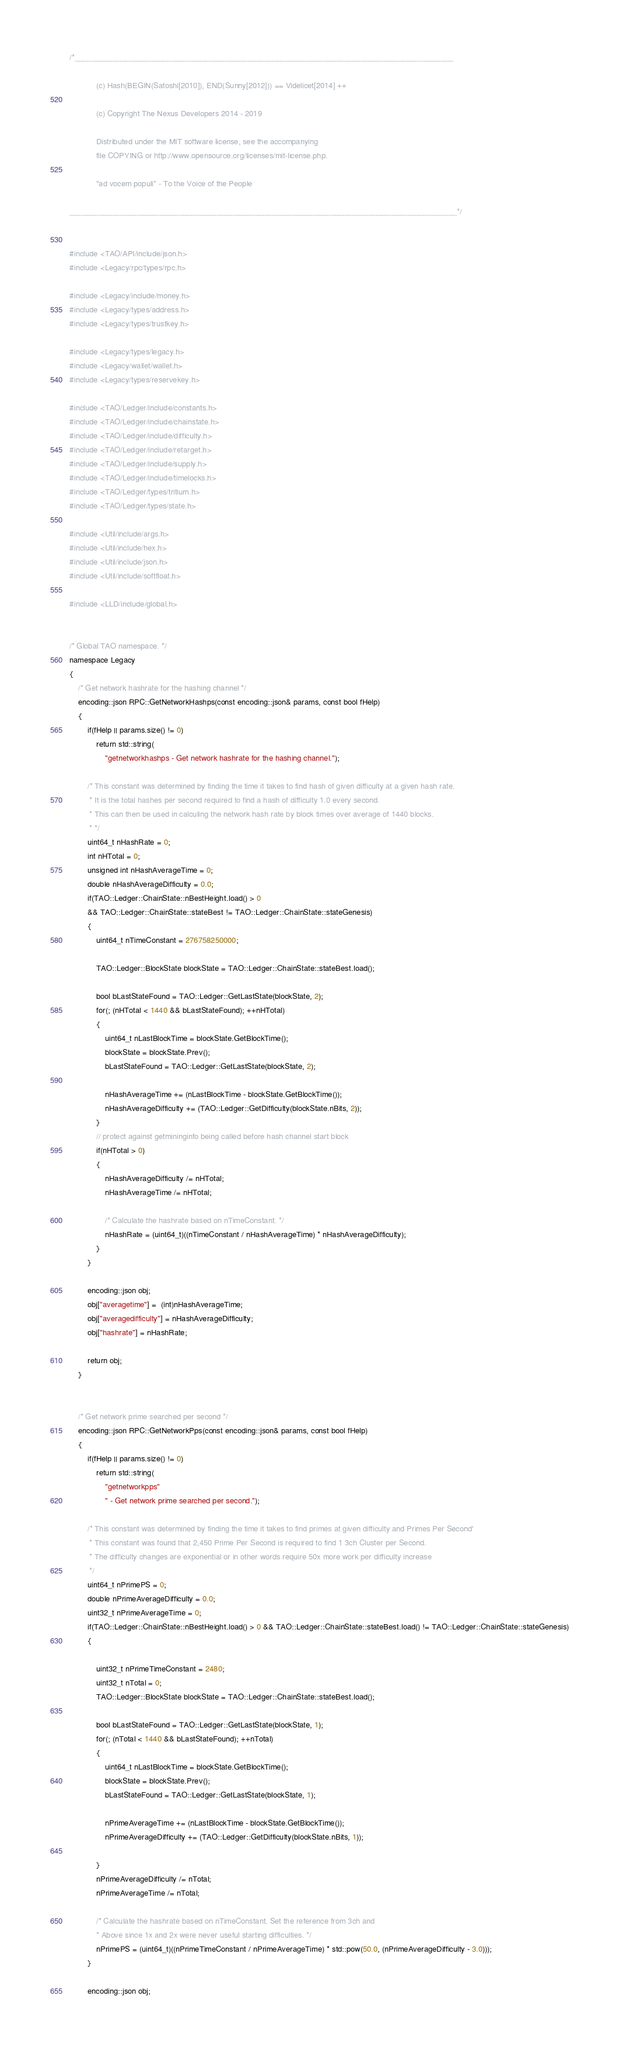Convert code to text. <code><loc_0><loc_0><loc_500><loc_500><_C++_>/*__________________________________________________________________________________________

            (c) Hash(BEGIN(Satoshi[2010]), END(Sunny[2012])) == Videlicet[2014] ++

            (c) Copyright The Nexus Developers 2014 - 2019

            Distributed under the MIT software license, see the accompanying
            file COPYING or http://www.opensource.org/licenses/mit-license.php.

            "ad vocem populi" - To the Voice of the People

____________________________________________________________________________________________*/


#include <TAO/API/include/json.h>
#include <Legacy/rpc/types/rpc.h>

#include <Legacy/include/money.h>
#include <Legacy/types/address.h>
#include <Legacy/types/trustkey.h>

#include <Legacy/types/legacy.h>
#include <Legacy/wallet/wallet.h>
#include <Legacy/types/reservekey.h>

#include <TAO/Ledger/include/constants.h>
#include <TAO/Ledger/include/chainstate.h>
#include <TAO/Ledger/include/difficulty.h>
#include <TAO/Ledger/include/retarget.h>
#include <TAO/Ledger/include/supply.h>
#include <TAO/Ledger/include/timelocks.h>
#include <TAO/Ledger/types/tritium.h>
#include <TAO/Ledger/types/state.h>

#include <Util/include/args.h>
#include <Util/include/hex.h>
#include <Util/include/json.h>
#include <Util/include/softfloat.h>

#include <LLD/include/global.h>


/* Global TAO namespace. */
namespace Legacy
{
    /* Get network hashrate for the hashing channel */
    encoding::json RPC::GetNetworkHashps(const encoding::json& params, const bool fHelp)
    {
        if(fHelp || params.size() != 0)
            return std::string(
                "getnetworkhashps - Get network hashrate for the hashing channel.");

        /* This constant was determined by finding the time it takes to find hash of given difficulty at a given hash rate.
         * It is the total hashes per second required to find a hash of difficulty 1.0 every second.
         * This can then be used in calculing the network hash rate by block times over average of 1440 blocks.
         * */
        uint64_t nHashRate = 0;
        int nHTotal = 0;
        unsigned int nHashAverageTime = 0;
        double nHashAverageDifficulty = 0.0;
        if(TAO::Ledger::ChainState::nBestHeight.load() > 0
        && TAO::Ledger::ChainState::stateBest != TAO::Ledger::ChainState::stateGenesis)
        {
            uint64_t nTimeConstant = 276758250000;

            TAO::Ledger::BlockState blockState = TAO::Ledger::ChainState::stateBest.load();

            bool bLastStateFound = TAO::Ledger::GetLastState(blockState, 2);
            for(; (nHTotal < 1440 && bLastStateFound); ++nHTotal)
            {
                uint64_t nLastBlockTime = blockState.GetBlockTime();
                blockState = blockState.Prev();
                bLastStateFound = TAO::Ledger::GetLastState(blockState, 2);

                nHashAverageTime += (nLastBlockTime - blockState.GetBlockTime());
                nHashAverageDifficulty += (TAO::Ledger::GetDifficulty(blockState.nBits, 2));
            }
            // protect against getmininginfo being called before hash channel start block
            if(nHTotal > 0)
            {
                nHashAverageDifficulty /= nHTotal;
                nHashAverageTime /= nHTotal;

                /* Calculate the hashrate based on nTimeConstant. */
                nHashRate = (uint64_t)((nTimeConstant / nHashAverageTime) * nHashAverageDifficulty);
            }
        }

        encoding::json obj;
        obj["averagetime"] =  (int)nHashAverageTime;
        obj["averagedifficulty"] = nHashAverageDifficulty;
        obj["hashrate"] = nHashRate;

        return obj;
    }


    /* Get network prime searched per second */
    encoding::json RPC::GetNetworkPps(const encoding::json& params, const bool fHelp)
    {
        if(fHelp || params.size() != 0)
            return std::string(
                "getnetworkpps"
                " - Get network prime searched per second.");

        /* This constant was determined by finding the time it takes to find primes at given difficulty and Primes Per Second'
         * This constant was found that 2,450 Prime Per Second is required to find 1 3ch Cluster per Second.
         * The difficulty changes are exponential or in other words require 50x more work per difficulty increase
         */
        uint64_t nPrimePS = 0;
        double nPrimeAverageDifficulty = 0.0;
        uint32_t nPrimeAverageTime = 0;
        if(TAO::Ledger::ChainState::nBestHeight.load() > 0 && TAO::Ledger::ChainState::stateBest.load() != TAO::Ledger::ChainState::stateGenesis)
        {

            uint32_t nPrimeTimeConstant = 2480;
            uint32_t nTotal = 0;
            TAO::Ledger::BlockState blockState = TAO::Ledger::ChainState::stateBest.load();

            bool bLastStateFound = TAO::Ledger::GetLastState(blockState, 1);
            for(; (nTotal < 1440 && bLastStateFound); ++nTotal)
            {
                uint64_t nLastBlockTime = blockState.GetBlockTime();
                blockState = blockState.Prev();
                bLastStateFound = TAO::Ledger::GetLastState(blockState, 1);

                nPrimeAverageTime += (nLastBlockTime - blockState.GetBlockTime());
                nPrimeAverageDifficulty += (TAO::Ledger::GetDifficulty(blockState.nBits, 1));

            }
            nPrimeAverageDifficulty /= nTotal;
            nPrimeAverageTime /= nTotal;

            /* Calculate the hashrate based on nTimeConstant. Set the reference from 3ch and
            * Above since 1x and 2x were never useful starting difficulties. */
            nPrimePS = (uint64_t)((nPrimeTimeConstant / nPrimeAverageTime) * std::pow(50.0, (nPrimeAverageDifficulty - 3.0)));
        }

        encoding::json obj;</code> 